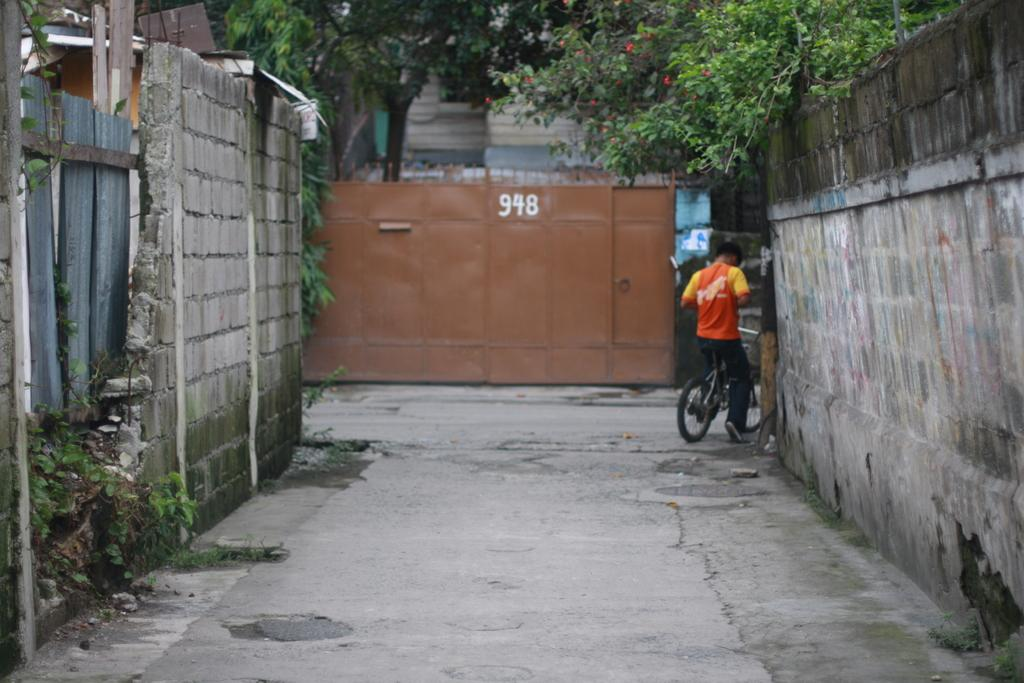<image>
Summarize the visual content of the image. A man riding a bike down an alleyway with the numbers 948 written on a wall at the far end. 